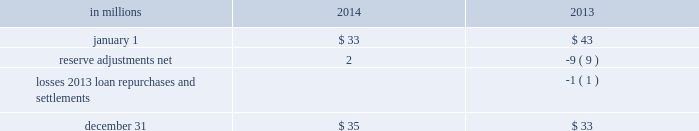Visa indemnification our payment services business issues and acquires credit and debit card transactions through visa u.s.a .
Inc .
Card association or its affiliates ( visa ) .
In october 2007 , visa completed a restructuring and issued shares of visa inc .
Common stock to its financial institution members ( visa reorganization ) in contemplation of its initial public offering ( ipo ) .
As part of the visa reorganization , we received our proportionate share of class b visa inc .
Common stock allocated to the u.s .
Members .
Prior to the ipo , the u.s .
Members , which included pnc , were obligated to indemnify visa for judgments and settlements related to certain specified litigation .
As a result of the acquisition of national city , we became party to judgment and loss sharing agreements with visa and certain other banks .
The judgment and loss sharing agreements were designed to apportion financial responsibilities arising from any potential adverse judgment or negotiated settlements related to the specified litigation .
In september 2014 , visa funded $ 450 million into its litigation escrow account and reduced the conversion rate of visa b to a shares .
We continue to have an obligation to indemnify visa for judgments and settlements for the remaining specified litigation .
Recourse and repurchase obligations as discussed in note 2 loan sale and servicing activities and variable interest entities , pnc has sold commercial mortgage , residential mortgage and home equity loans/ lines of credit directly or indirectly through securitization and loan sale transactions in which we have continuing involvement .
One form of continuing involvement includes certain recourse and loan repurchase obligations associated with the transferred assets .
Commercial mortgage loan recourse obligations we originate and service certain multi-family commercial mortgage loans which are sold to fnma under fnma 2019s delegated underwriting and servicing ( dus ) program .
We participated in a similar program with the fhlmc .
Under these programs , we generally assume up to a one-third pari passu risk of loss on unpaid principal balances through a loss share arrangement .
At december 31 , 2014 and december 31 , 2013 , the unpaid principal balance outstanding of loans sold as a participant in these programs was $ 12.3 billion and $ 11.7 billion , respectively .
The potential maximum exposure under the loss share arrangements was $ 3.7 billion at december 31 , 2014 and $ 3.6 billion at december 31 , 2013 .
We maintain a reserve for estimated losses based upon our exposure .
The reserve for losses under these programs totaled $ 35 million and $ 33 million as of december 31 , 2014 and december 31 , 2013 , respectively , and is included in other liabilities on our consolidated balance sheet .
If payment is required under these programs , we would not have a contractual interest in the collateral underlying the mortgage loans on which losses occurred , although the value of the collateral is taken into account in determining our share of such losses .
Our exposure and activity associated with these recourse obligations are reported in the corporate & institutional banking segment .
Table 150 : analysis of commercial mortgage recourse obligations .
Residential mortgage loan and home equity loan/ line of credit repurchase obligations while residential mortgage loans are sold on a non-recourse basis , we assume certain loan repurchase obligations associated with mortgage loans we have sold to investors .
These loan repurchase obligations primarily relate to situations where pnc is alleged to have breached certain origination covenants and representations and warranties made to purchasers of the loans in the respective purchase and sale agreements .
Repurchase obligation activity associated with residential mortgages is reported in the residential mortgage banking segment .
In the fourth quarter of 2013 , pnc reached agreements with both fnma and fhlmc to resolve their repurchase claims with respect to loans sold between 2000 and 2008 .
Pnc paid a total of $ 191 million related to these settlements .
Pnc 2019s repurchase obligations also include certain brokered home equity loans/lines of credit that were sold to a limited number of private investors in the financial services industry by national city prior to our acquisition of national city .
Pnc is no longer engaged in the brokered home equity lending business , and our exposure under these loan repurchase obligations is limited to repurchases of loans sold in these transactions .
Repurchase activity associated with brokered home equity loans/lines of credit is reported in the non-strategic assets portfolio segment .
214 the pnc financial services group , inc .
2013 form 10-k .
What was the average balance in millions for commercial mortgage recourse obligations as of december 31 2014 and 2013? 
Computations: ((35 + 33) / 2)
Answer: 34.0. Visa indemnification our payment services business issues and acquires credit and debit card transactions through visa u.s.a .
Inc .
Card association or its affiliates ( visa ) .
In october 2007 , visa completed a restructuring and issued shares of visa inc .
Common stock to its financial institution members ( visa reorganization ) in contemplation of its initial public offering ( ipo ) .
As part of the visa reorganization , we received our proportionate share of class b visa inc .
Common stock allocated to the u.s .
Members .
Prior to the ipo , the u.s .
Members , which included pnc , were obligated to indemnify visa for judgments and settlements related to certain specified litigation .
As a result of the acquisition of national city , we became party to judgment and loss sharing agreements with visa and certain other banks .
The judgment and loss sharing agreements were designed to apportion financial responsibilities arising from any potential adverse judgment or negotiated settlements related to the specified litigation .
In september 2014 , visa funded $ 450 million into its litigation escrow account and reduced the conversion rate of visa b to a shares .
We continue to have an obligation to indemnify visa for judgments and settlements for the remaining specified litigation .
Recourse and repurchase obligations as discussed in note 2 loan sale and servicing activities and variable interest entities , pnc has sold commercial mortgage , residential mortgage and home equity loans/ lines of credit directly or indirectly through securitization and loan sale transactions in which we have continuing involvement .
One form of continuing involvement includes certain recourse and loan repurchase obligations associated with the transferred assets .
Commercial mortgage loan recourse obligations we originate and service certain multi-family commercial mortgage loans which are sold to fnma under fnma 2019s delegated underwriting and servicing ( dus ) program .
We participated in a similar program with the fhlmc .
Under these programs , we generally assume up to a one-third pari passu risk of loss on unpaid principal balances through a loss share arrangement .
At december 31 , 2014 and december 31 , 2013 , the unpaid principal balance outstanding of loans sold as a participant in these programs was $ 12.3 billion and $ 11.7 billion , respectively .
The potential maximum exposure under the loss share arrangements was $ 3.7 billion at december 31 , 2014 and $ 3.6 billion at december 31 , 2013 .
We maintain a reserve for estimated losses based upon our exposure .
The reserve for losses under these programs totaled $ 35 million and $ 33 million as of december 31 , 2014 and december 31 , 2013 , respectively , and is included in other liabilities on our consolidated balance sheet .
If payment is required under these programs , we would not have a contractual interest in the collateral underlying the mortgage loans on which losses occurred , although the value of the collateral is taken into account in determining our share of such losses .
Our exposure and activity associated with these recourse obligations are reported in the corporate & institutional banking segment .
Table 150 : analysis of commercial mortgage recourse obligations .
Residential mortgage loan and home equity loan/ line of credit repurchase obligations while residential mortgage loans are sold on a non-recourse basis , we assume certain loan repurchase obligations associated with mortgage loans we have sold to investors .
These loan repurchase obligations primarily relate to situations where pnc is alleged to have breached certain origination covenants and representations and warranties made to purchasers of the loans in the respective purchase and sale agreements .
Repurchase obligation activity associated with residential mortgages is reported in the residential mortgage banking segment .
In the fourth quarter of 2013 , pnc reached agreements with both fnma and fhlmc to resolve their repurchase claims with respect to loans sold between 2000 and 2008 .
Pnc paid a total of $ 191 million related to these settlements .
Pnc 2019s repurchase obligations also include certain brokered home equity loans/lines of credit that were sold to a limited number of private investors in the financial services industry by national city prior to our acquisition of national city .
Pnc is no longer engaged in the brokered home equity lending business , and our exposure under these loan repurchase obligations is limited to repurchases of loans sold in these transactions .
Repurchase activity associated with brokered home equity loans/lines of credit is reported in the non-strategic assets portfolio segment .
214 the pnc financial services group , inc .
2013 form 10-k .
What was the change in millions for commercial mortgage recourse obligations between december 31 2014 and 2013? 
Computations: (35 - 33)
Answer: 2.0. 